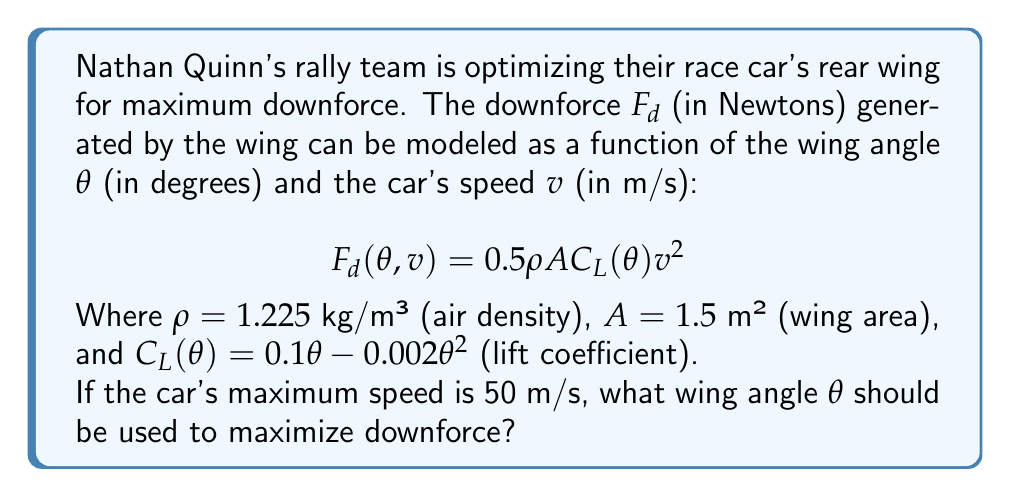Could you help me with this problem? To find the optimal wing angle, we need to maximize the downforce function with respect to $\theta$. Here's how we can do this:

1) First, let's substitute the given values into the downforce equation:

   $$F_d(\theta) = 0.5 \cdot 1.225 \cdot 1.5 \cdot (0.1\theta - 0.002\theta^2) \cdot 50^2$$

2) Simplify:

   $$F_d(\theta) = 229.6875 \cdot (0.1\theta - 0.002\theta^2)$$
   $$F_d(\theta) = 22.96875\theta - 0.45937\theta^2$$

3) To find the maximum, we need to find where the derivative of $F_d(\theta)$ equals zero:

   $$\frac{d}{d\theta}F_d(\theta) = 22.96875 - 0.91874\theta$$

4) Set this equal to zero and solve for $\theta$:

   $$22.96875 - 0.91874\theta = 0$$
   $$0.91874\theta = 22.96875$$
   $$\theta = \frac{22.96875}{0.91874} \approx 25$$

5) To confirm this is a maximum (not a minimum), we can check the second derivative:

   $$\frac{d^2}{d\theta^2}F_d(\theta) = -0.91874$$

   This is negative, confirming we've found a maximum.

Therefore, the optimal wing angle is approximately 25 degrees.
Answer: 25 degrees 